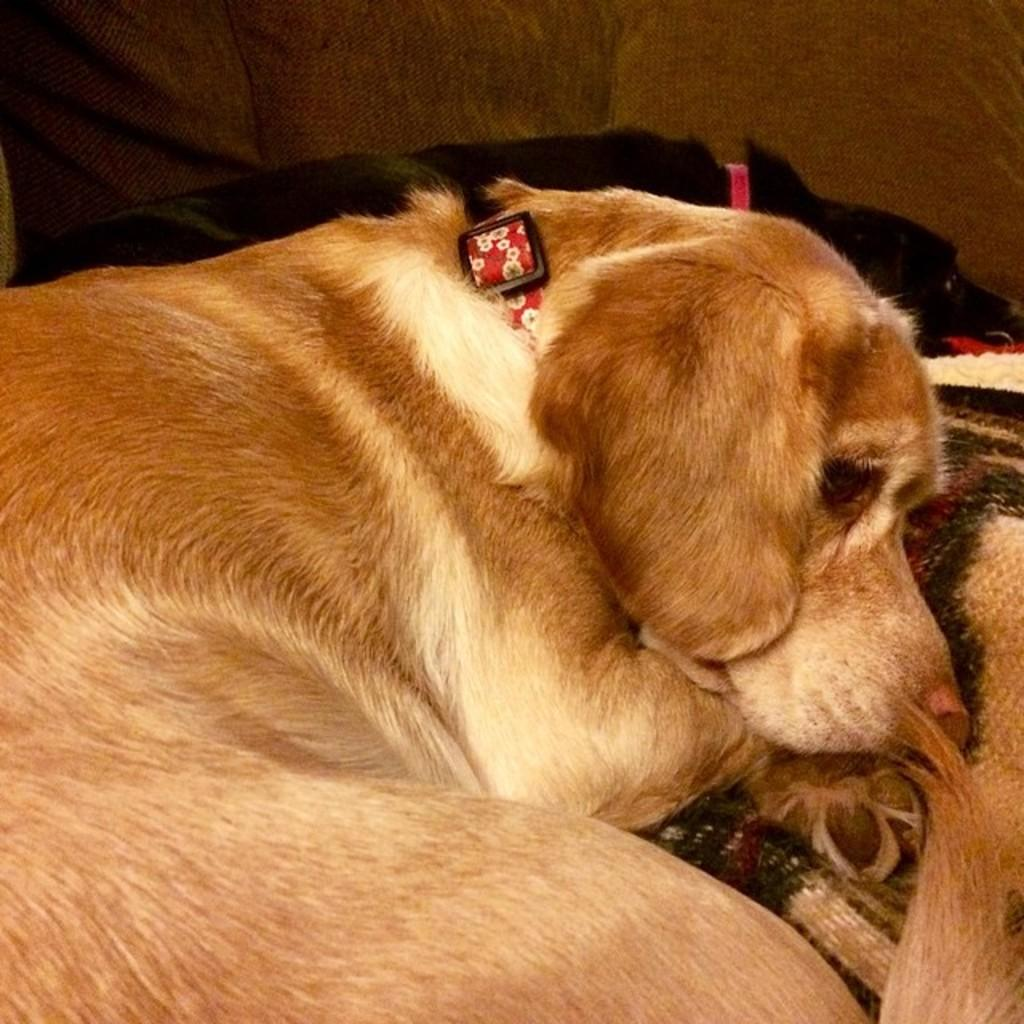What type of animal is in the picture? There is a dog in the picture. What is the dog doing in the picture? The dog is lying on a bed. What is the color of the dog? The dog is cream in color. Are there any other colors on the dog's body? Yes, the dog has some brown color on its body. What type of business is being conducted on the island in the picture? There is no island or business activity present in the image; it features a dog lying on a bed. What type of lead is the dog using to walk around in the picture? The dog is lying on a bed and not walking, so there is no lead present in the image. 